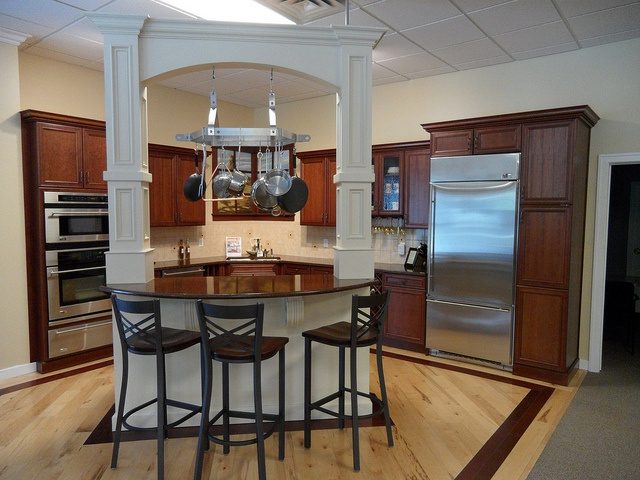Describe the objects in this image and their specific colors. I can see refrigerator in gray, darkgray, lightblue, and black tones, oven in gray, black, and maroon tones, chair in gray, black, and navy tones, chair in gray and black tones, and chair in gray, black, and darkgray tones in this image. 